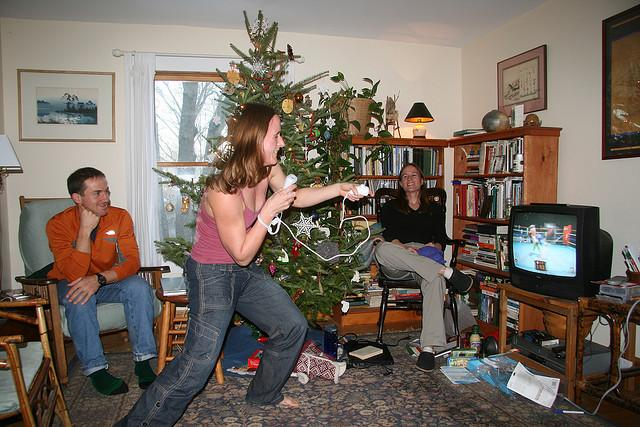What type of television display technology is being used in the living room? Please explain your reasoning. crt. It's a crt. 